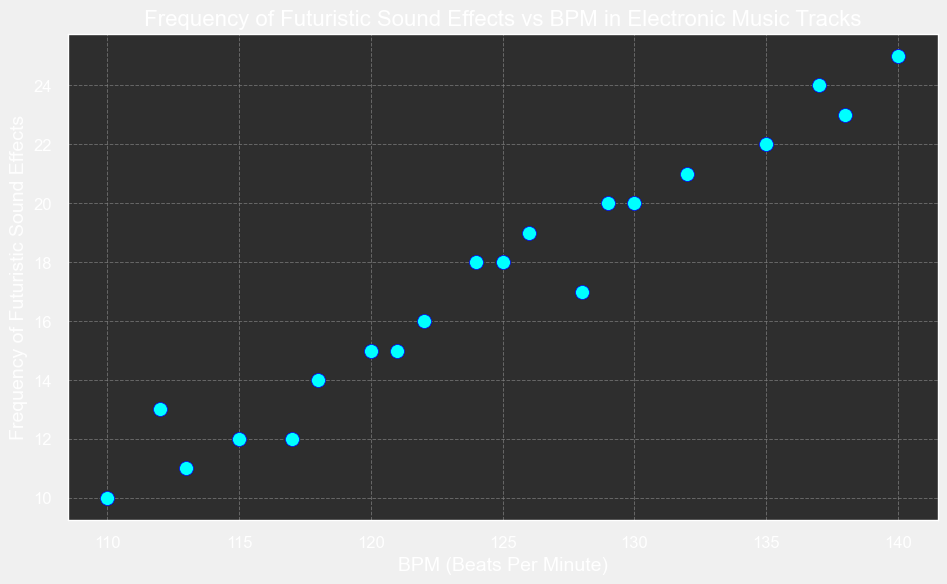What's the highest frequency of futuristic sound effects in the tracks? Look for the highest point on the y-axis labeled 'Frequency of Futuristic Sound Effects'. The highest point corresponds to 25 effects.
Answer: 25 Which track has the highest BPM? Find the point that is farthest to the right on the x-axis labeled 'BPM'. The highest BPM indicated is 140.
Answer: Track4 How many tracks have a BPM of 130 or greater? Identify all points on the scatter plot at or to the right of the 130 BPM mark on the x-axis. There are 8 such points.
Answer: 8 What is the average frequency of futuristic sound effects for tracks with a BPM above 125? Identify the points with BPM above 125, then sum their frequencies and divide by the number of such points: (20 + 25 + 22 + 21 + 23 + 24 + 20 + 18) / 8 = 173 / 8 = 21.625.
Answer: 21.625 Which track has the lowest frequency of futuristic sound effects? Find the point that is lowest on the y-axis. The lowest point corresponds to 10 effects.
Answer: Track3 Is there a track with both high frequency of futuristic sound effects and high BPM? Look for points that are high on both axes. Track4 (25 effects, 140 BPM) has both high frequency and high BPM.
Answer: Track4 Are there any tracks with a BPM between 115 and 125 and a frequency of futuristic sound effects between 10 and 20? Check for points within the specified BPM range on the x-axis and within the specified frequency range on the y-axis. Track1 (120 BPM, 15 effects), Track5 (125 BPM, 18 effects), Track6 (115 BPM, 12 effects), Track8 (128 BPM, 17 effects), Track9 (118 BPM, 14 effects), Track11 (126 BPM, 19 effects), Track14 (122 BPM, 16 effects), Track15 (113 BPM, 11 effects), Track19 (124 BPM, 18 effects), and Track20 (121 BPM, 15 effects) all meet the criteria.
Answer: Yes What is the frequency of futuristic sound effects for Track7? Find Track7 data point on the scatter plot. The y-axis value for Track7 is 22.
Answer: 22 Which tracks have a frequency of futuristic sound effects above 20? Look for points that are above the 20 mark on the y-axis. There are Track4, Track7, Track10, Track13, and Track16.
Answer: Track4, Track7, Track10, Track13, Track16 